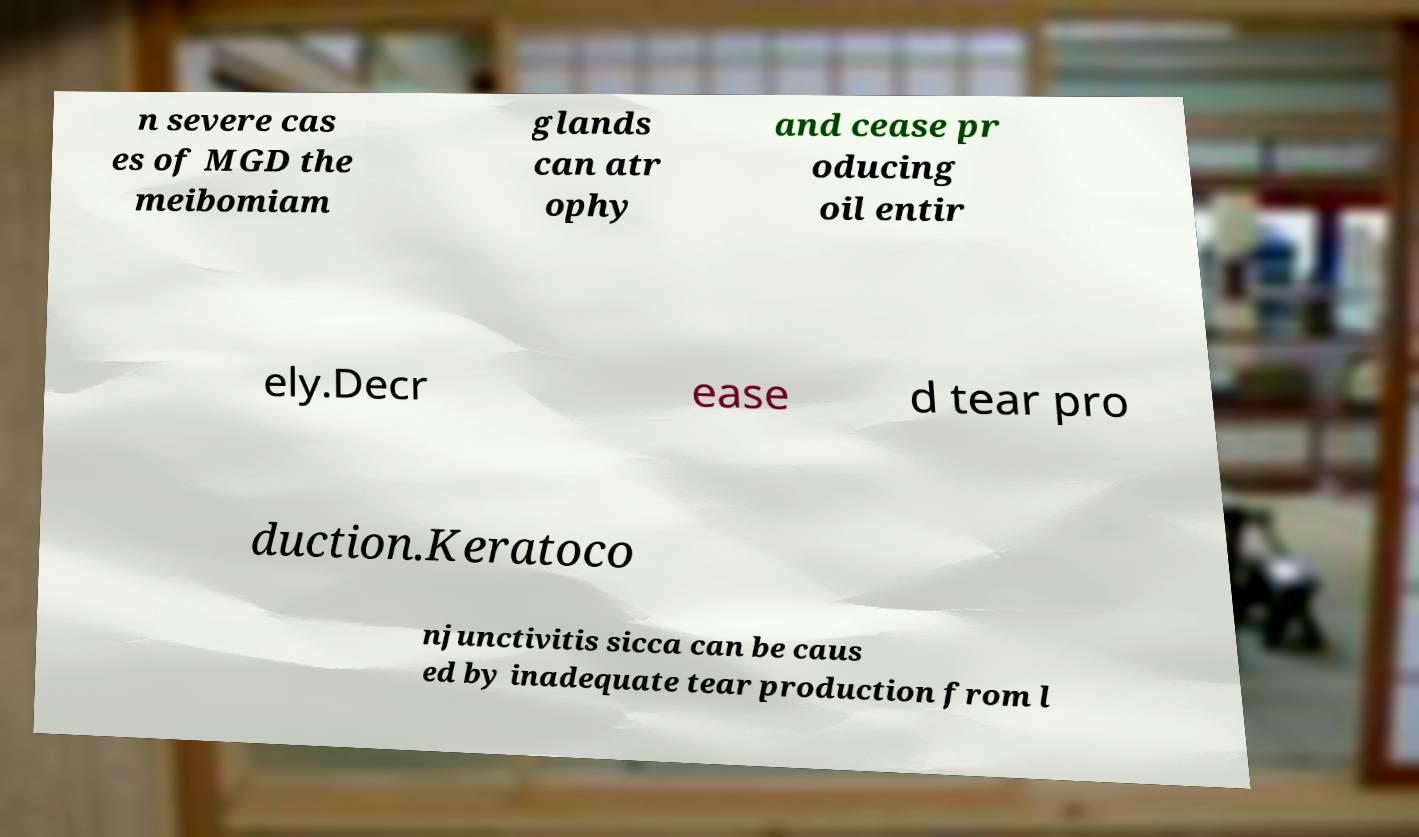Please read and relay the text visible in this image. What does it say? n severe cas es of MGD the meibomiam glands can atr ophy and cease pr oducing oil entir ely.Decr ease d tear pro duction.Keratoco njunctivitis sicca can be caus ed by inadequate tear production from l 